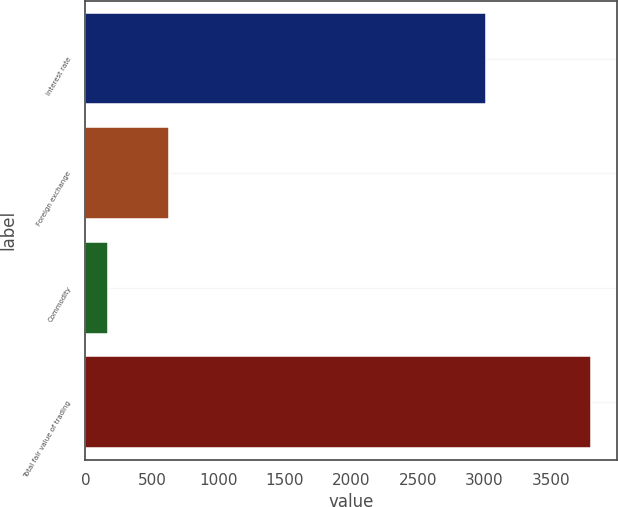Convert chart to OTSL. <chart><loc_0><loc_0><loc_500><loc_500><bar_chart><fcel>Interest rate<fcel>Foreign exchange<fcel>Commodity<fcel>Total fair value of trading<nl><fcel>3011<fcel>626<fcel>168<fcel>3805<nl></chart> 